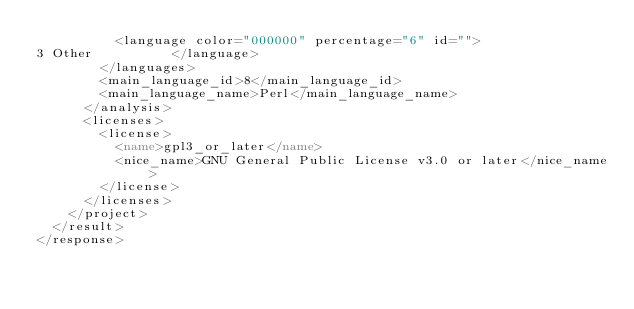<code> <loc_0><loc_0><loc_500><loc_500><_XML_>          <language color="000000" percentage="6" id="">
3 Other          </language>
        </languages>
        <main_language_id>8</main_language_id>
        <main_language_name>Perl</main_language_name>
      </analysis>
      <licenses>
        <license>
          <name>gpl3_or_later</name>
          <nice_name>GNU General Public License v3.0 or later</nice_name>
        </license>
      </licenses>
    </project>
  </result>
</response>
</code> 